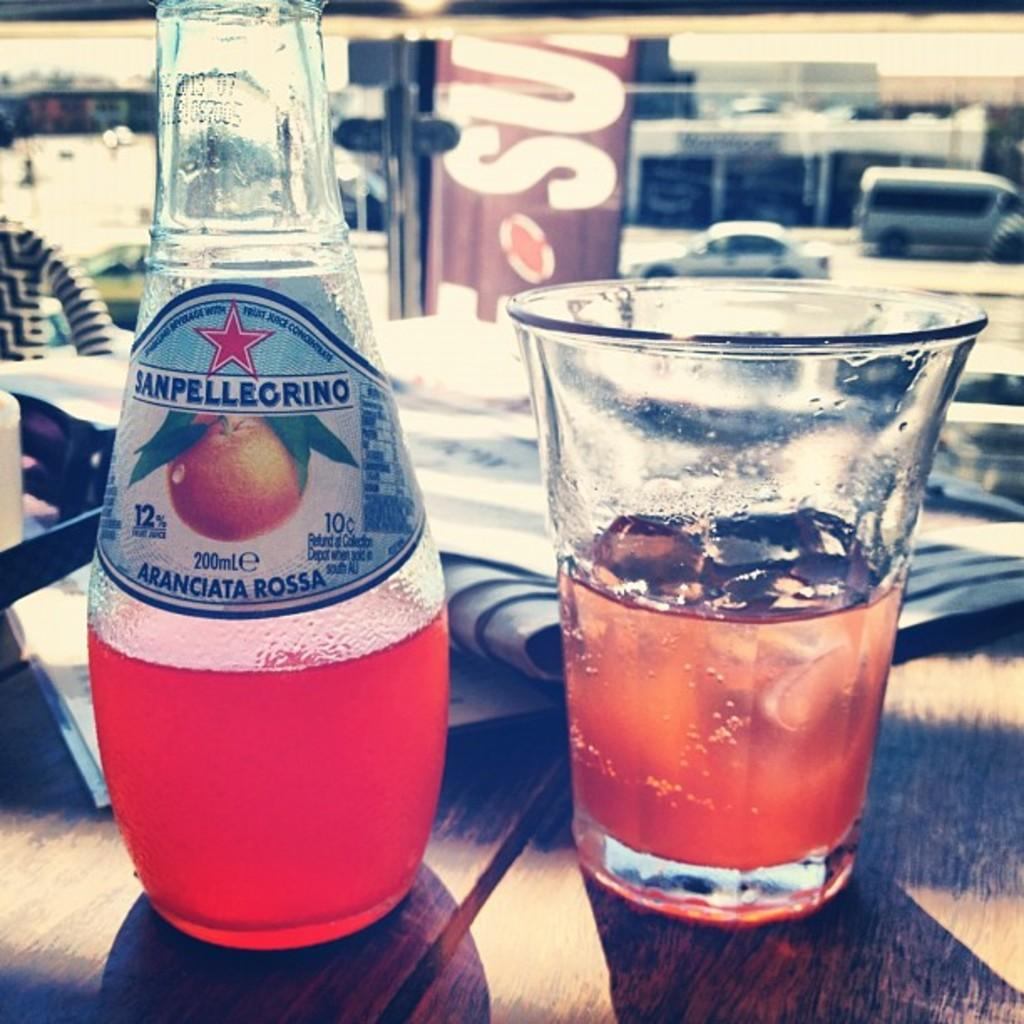What is present on the table in the image? There is a bottle and a glass on the table in the image. What else can be seen on the table besides the bottle and glass? Papers are present on the table. Can you describe the background of the image? In the background, there are vehicles moving on the road. What type of crown is being exchanged between the vehicles in the background? There is no crown present in the image, nor is there any exchange between the vehicles in the background. 